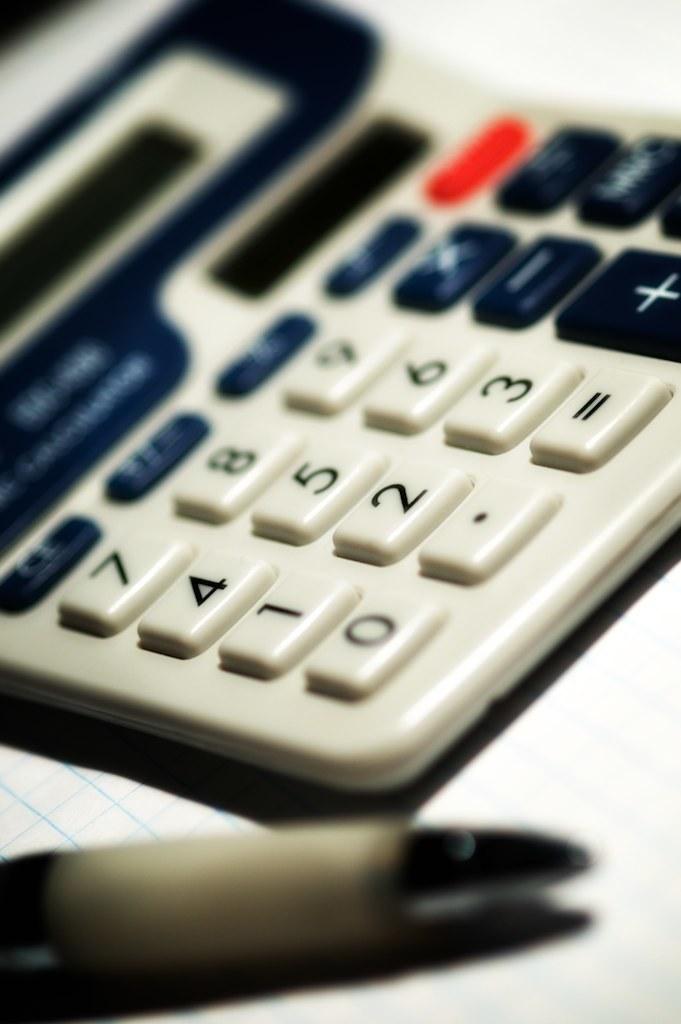What number button is between 1 and  7 on on the calculator?
Give a very brief answer. 4. Is the calculator functional?
Your answer should be compact. Unanswerable. 